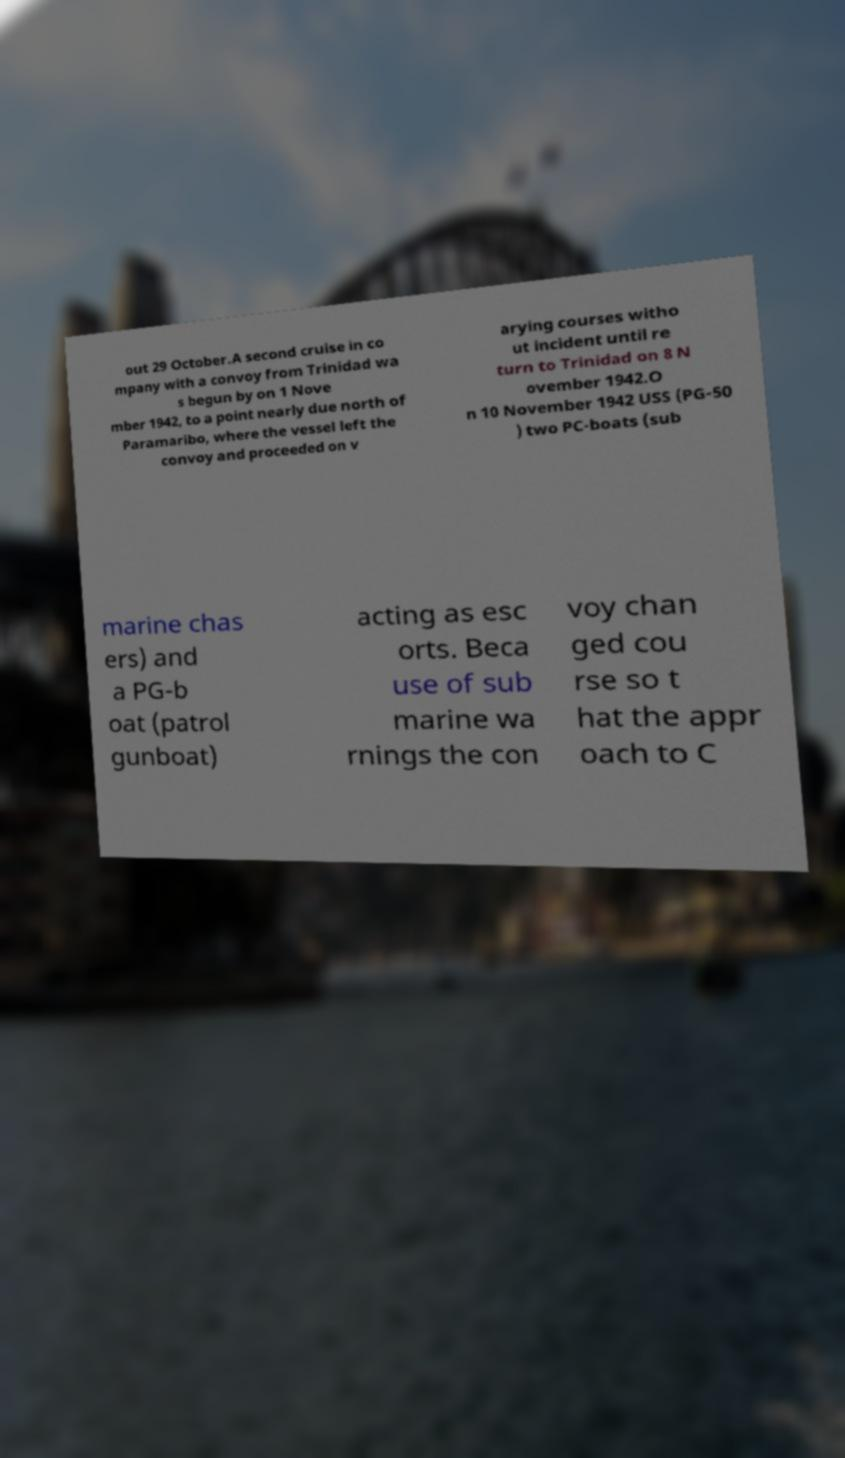What messages or text are displayed in this image? I need them in a readable, typed format. out 29 October.A second cruise in co mpany with a convoy from Trinidad wa s begun by on 1 Nove mber 1942, to a point nearly due north of Paramaribo, where the vessel left the convoy and proceeded on v arying courses witho ut incident until re turn to Trinidad on 8 N ovember 1942.O n 10 November 1942 USS (PG-50 ) two PC-boats (sub marine chas ers) and a PG-b oat (patrol gunboat) acting as esc orts. Beca use of sub marine wa rnings the con voy chan ged cou rse so t hat the appr oach to C 